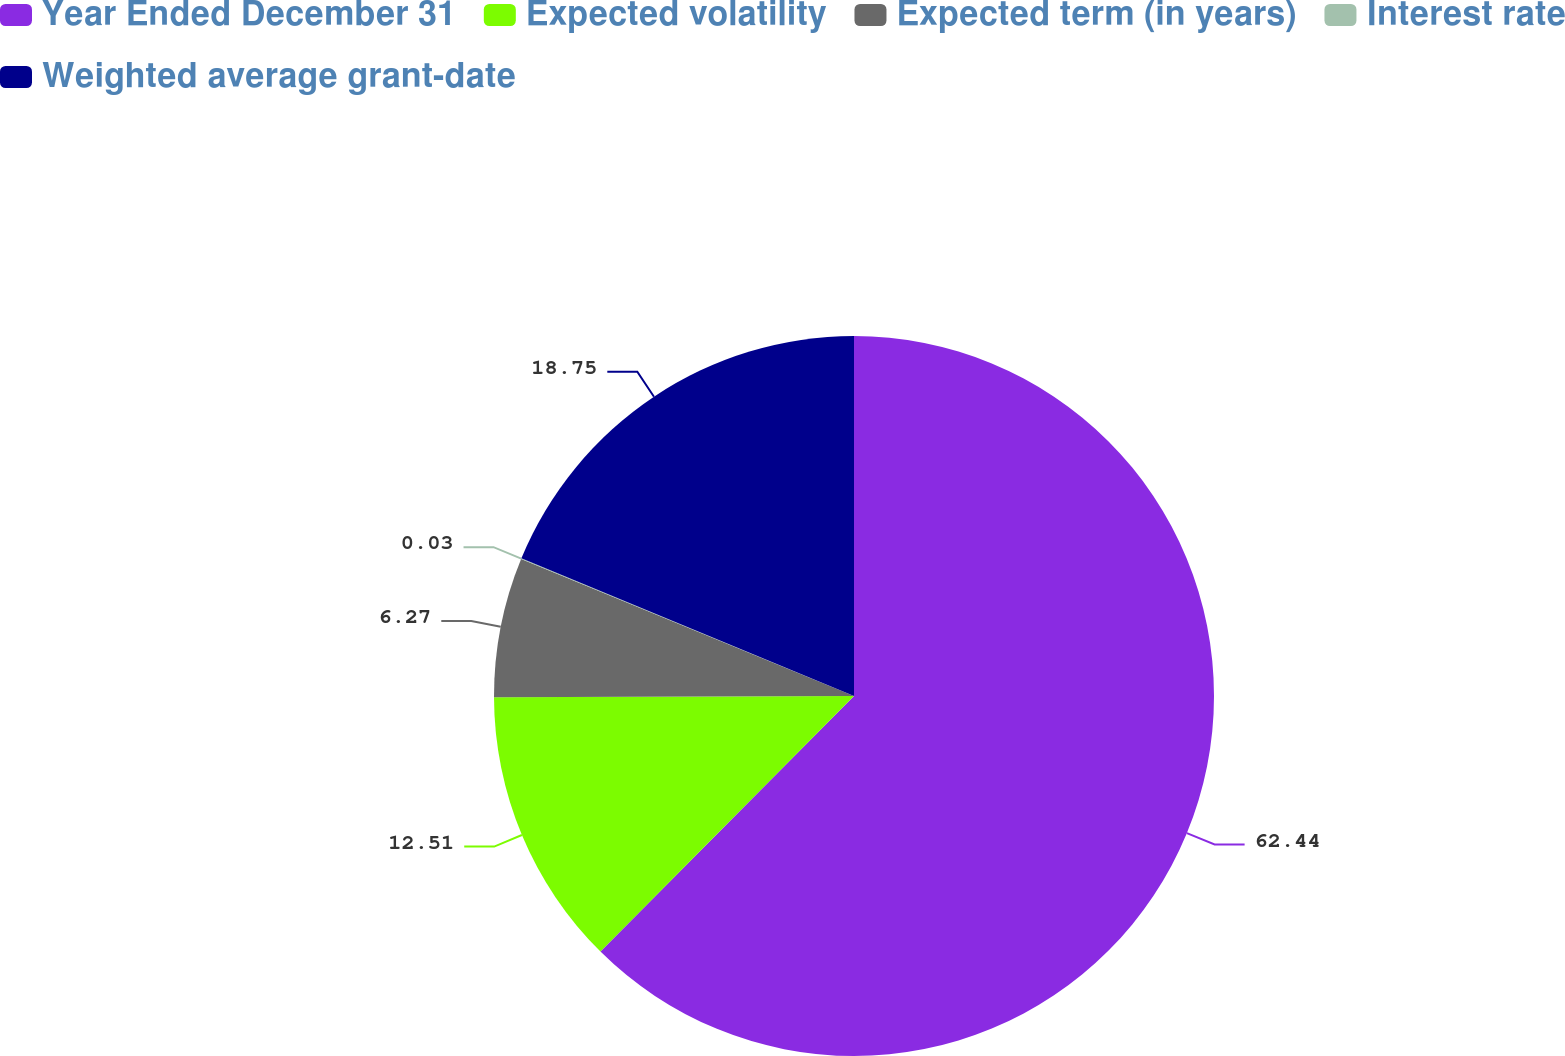Convert chart. <chart><loc_0><loc_0><loc_500><loc_500><pie_chart><fcel>Year Ended December 31<fcel>Expected volatility<fcel>Expected term (in years)<fcel>Interest rate<fcel>Weighted average grant-date<nl><fcel>62.43%<fcel>12.51%<fcel>6.27%<fcel>0.03%<fcel>18.75%<nl></chart> 